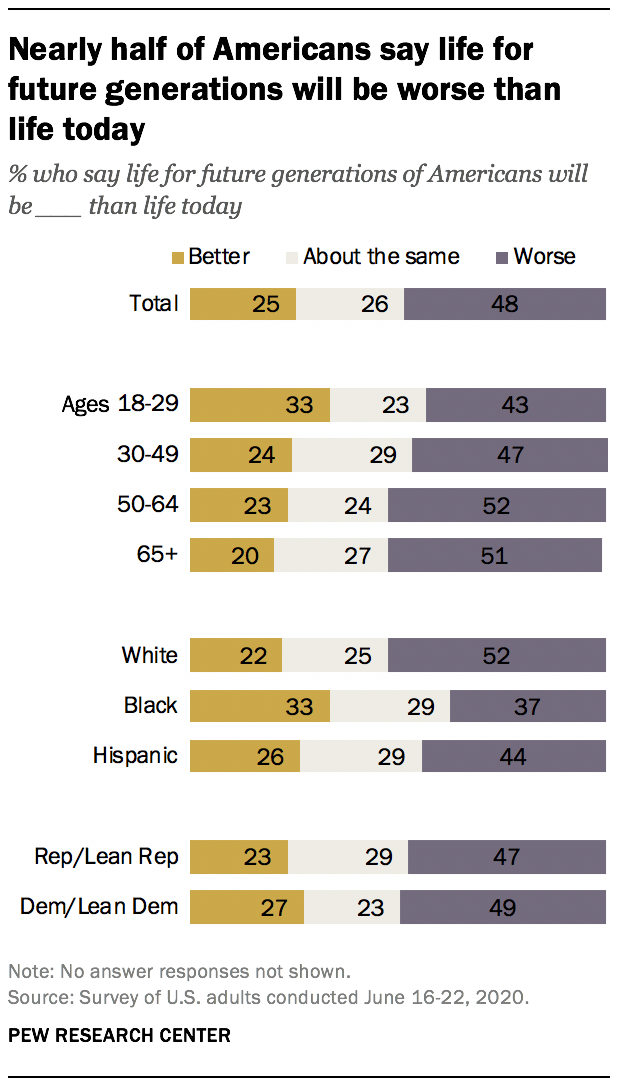Indicate a few pertinent items in this graphic. Based on the data, it can be concluded that 0.51% of people believe that life will be the same or better. The purple color in the graph represents a worsening trend. 